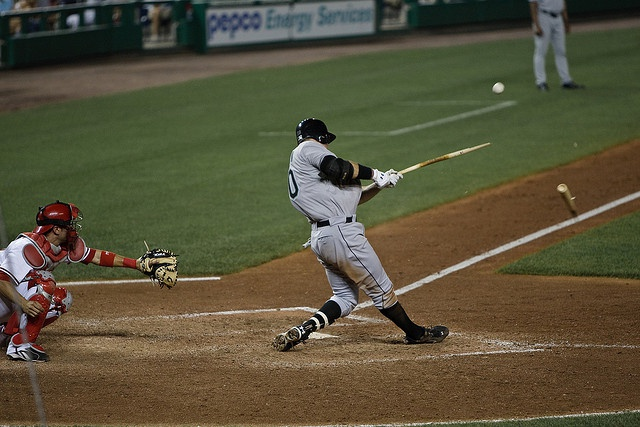Describe the objects in this image and their specific colors. I can see people in purple, darkgray, black, gray, and lightgray tones, people in purple, black, maroon, gray, and lavender tones, people in purple, gray, and black tones, baseball glove in purple, black, tan, olive, and gray tones, and baseball bat in purple, darkgreen, tan, beige, and olive tones in this image. 